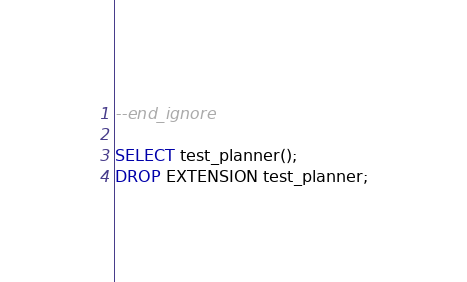<code> <loc_0><loc_0><loc_500><loc_500><_SQL_>--end_ignore

SELECT test_planner();
DROP EXTENSION test_planner;
</code> 